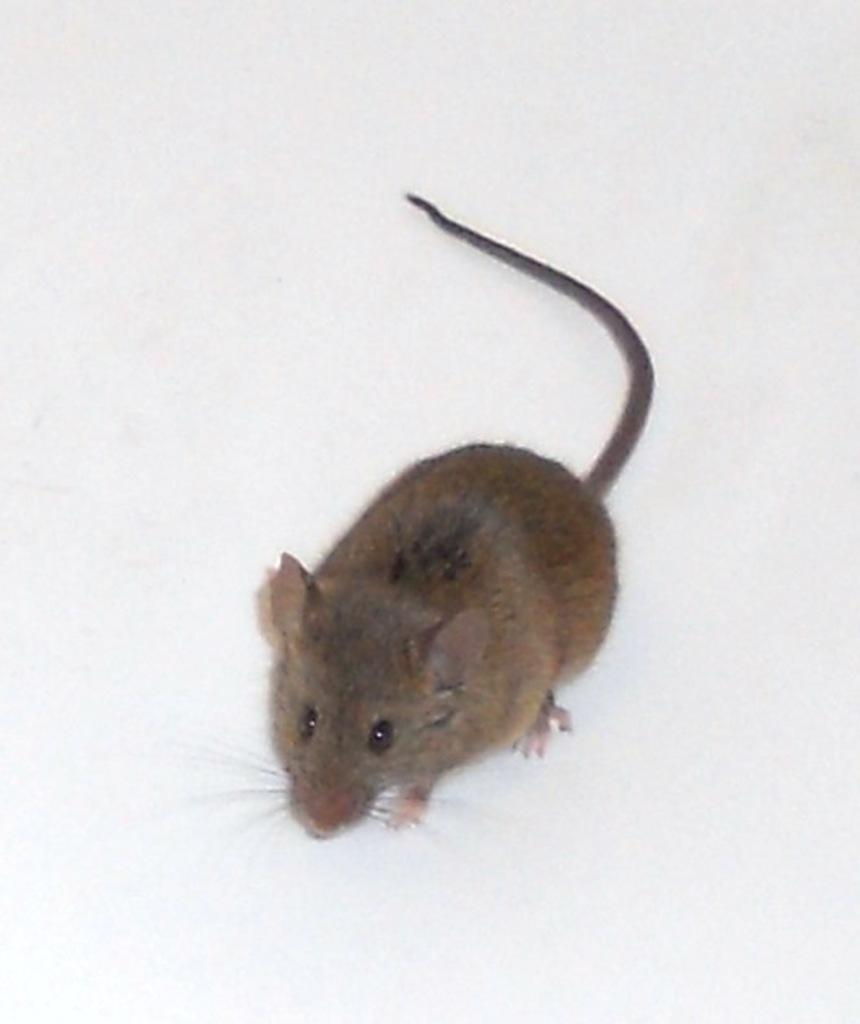What animal is present in the image? There is a rat in the image. What is the color of the surface the rat is on? The rat is on a white surface. Can you see any caves in the image? There are no caves present in the image. Is the rat shown crushing any objects in the image? The rat is not shown crushing any objects in the image. 